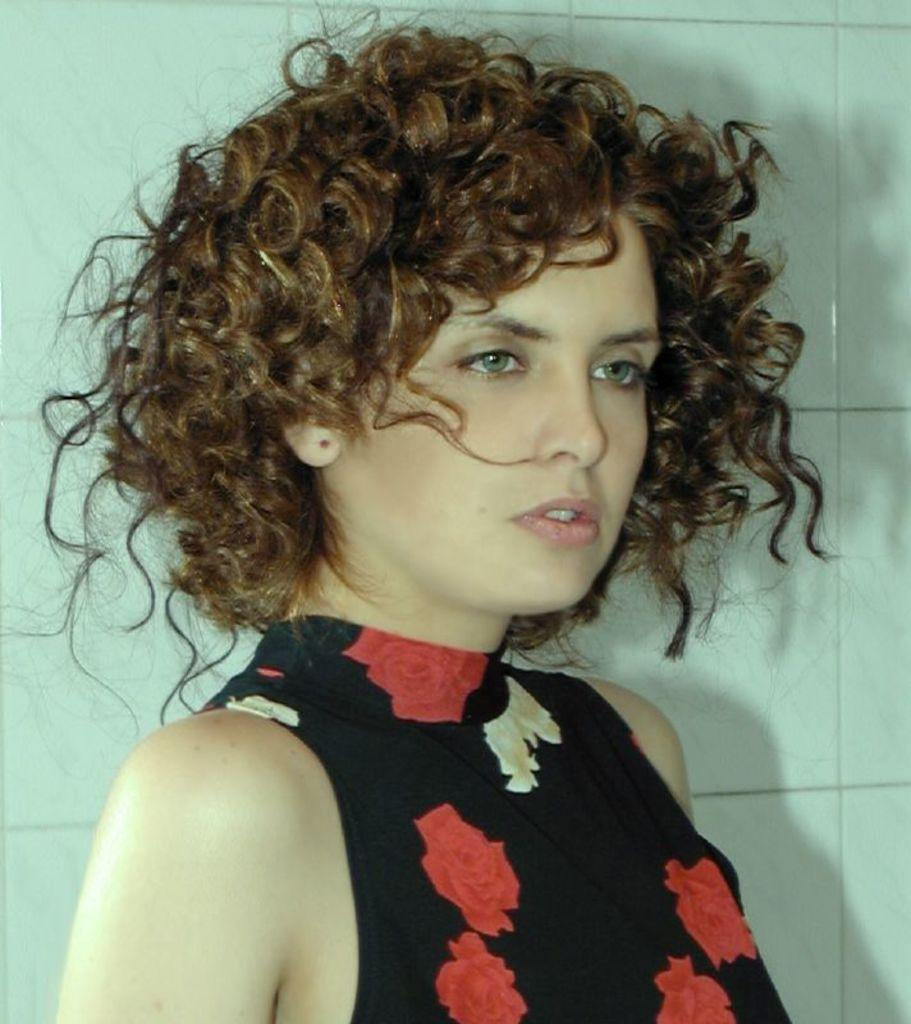Who is the main subject in the image? There is a woman in the image. What is the woman wearing? The woman is wearing clothes. What type of flooring can be seen in the image? There are white tiles in the image. Can you describe any accessories the woman is wearing? The woman is wearing an earring stud. What type of stick does the woman use to learn in the image? There is no stick or learning activity depicted in the image. 